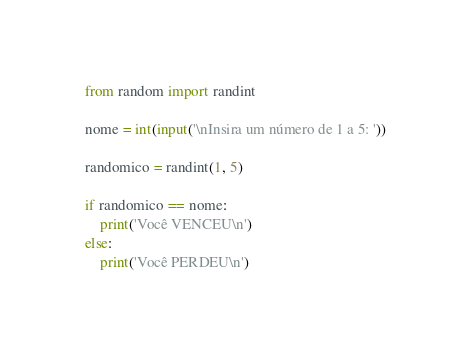Convert code to text. <code><loc_0><loc_0><loc_500><loc_500><_Python_>from random import randint

nome = int(input('\nInsira um número de 1 a 5: '))

randomico = randint(1, 5)

if randomico == nome:
    print('Você VENCEU\n')
else:
    print('Você PERDEU\n')
</code> 